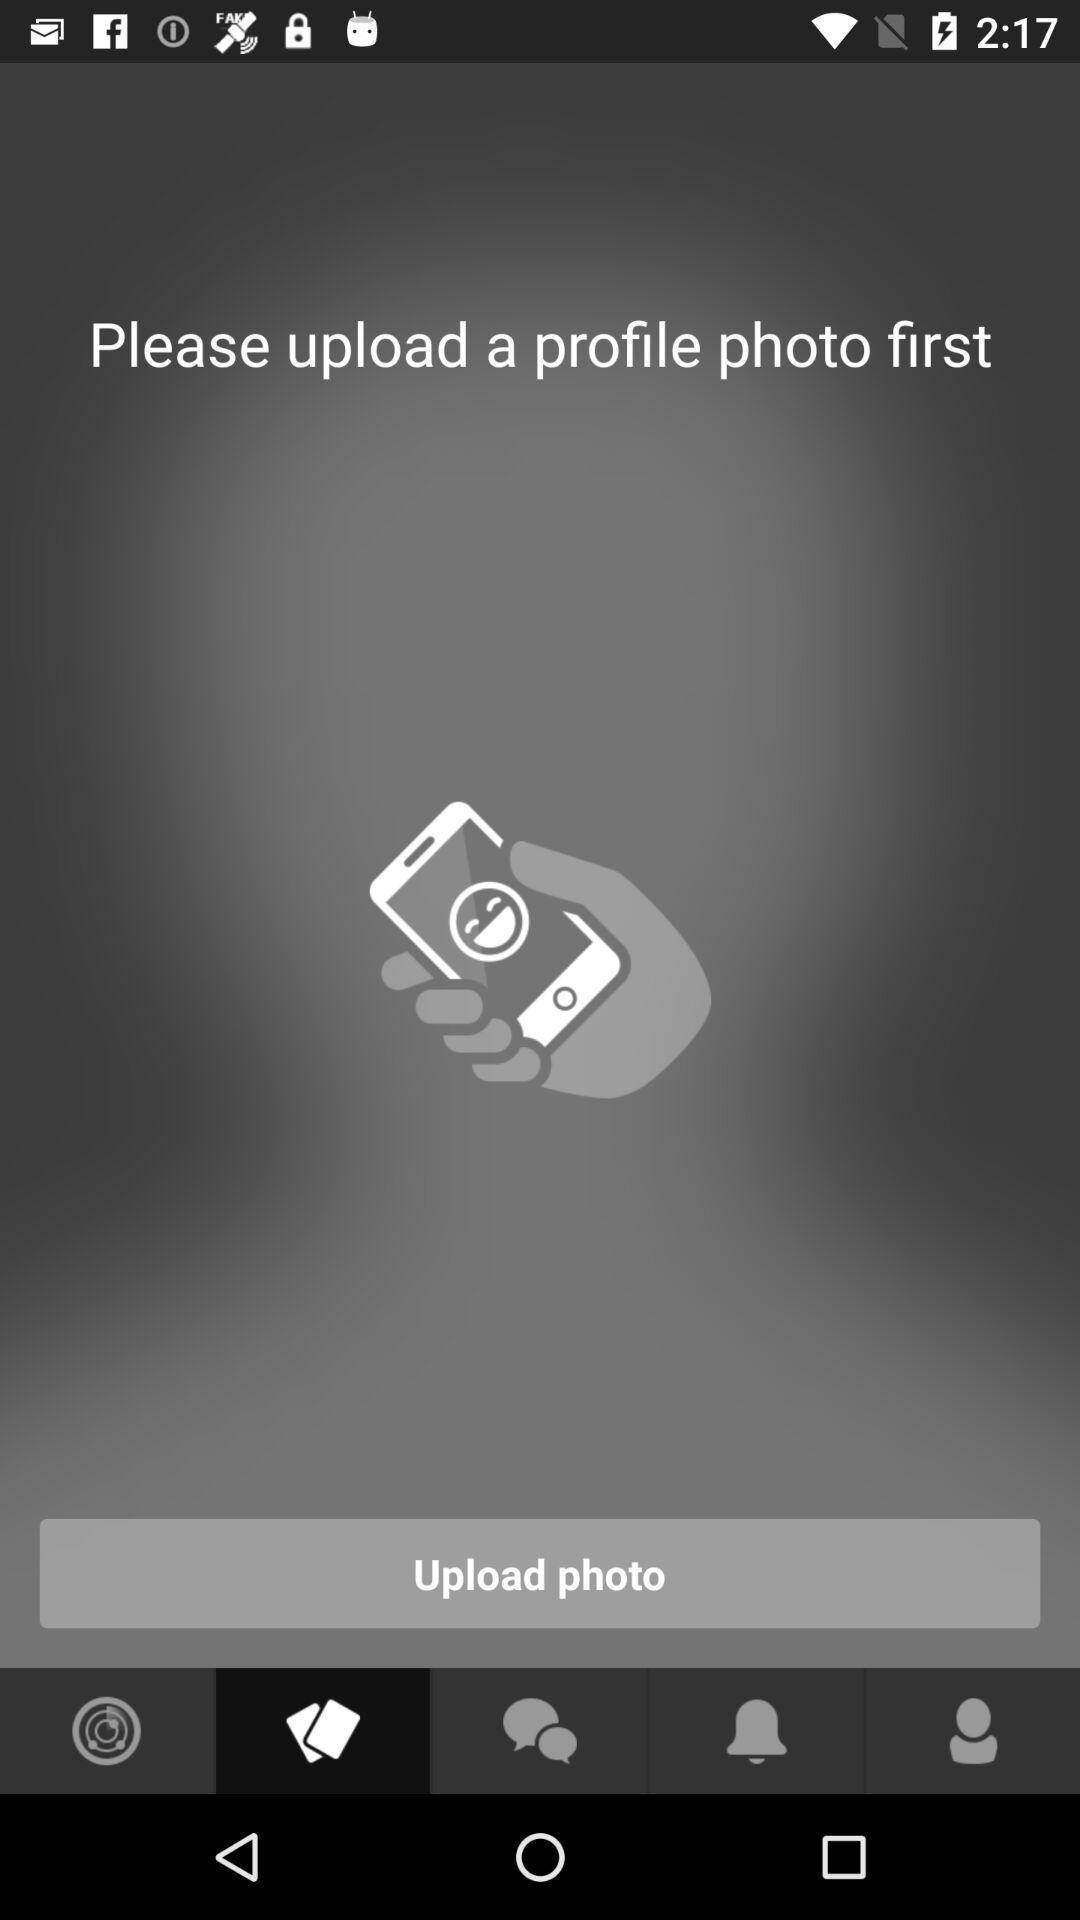Describe the key features of this screenshot. Page displaying the upload photo. 